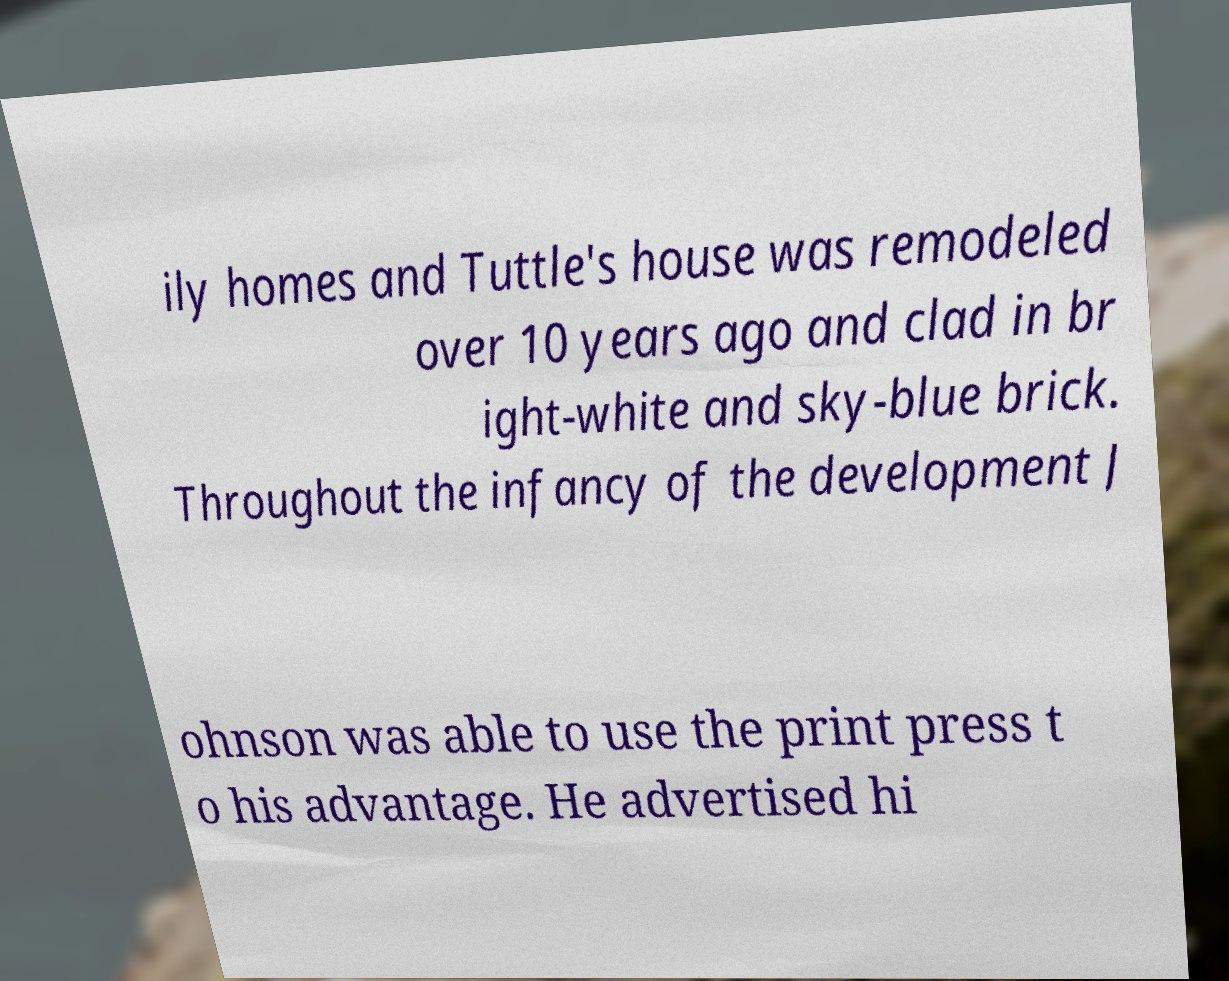There's text embedded in this image that I need extracted. Can you transcribe it verbatim? ily homes and Tuttle's house was remodeled over 10 years ago and clad in br ight-white and sky-blue brick. Throughout the infancy of the development J ohnson was able to use the print press t o his advantage. He advertised hi 